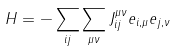<formula> <loc_0><loc_0><loc_500><loc_500>H = - \sum _ { i j } \sum _ { \mu \nu } J _ { i j } ^ { \mu \nu } { e } _ { i , \mu } { e } _ { j , \nu }</formula> 